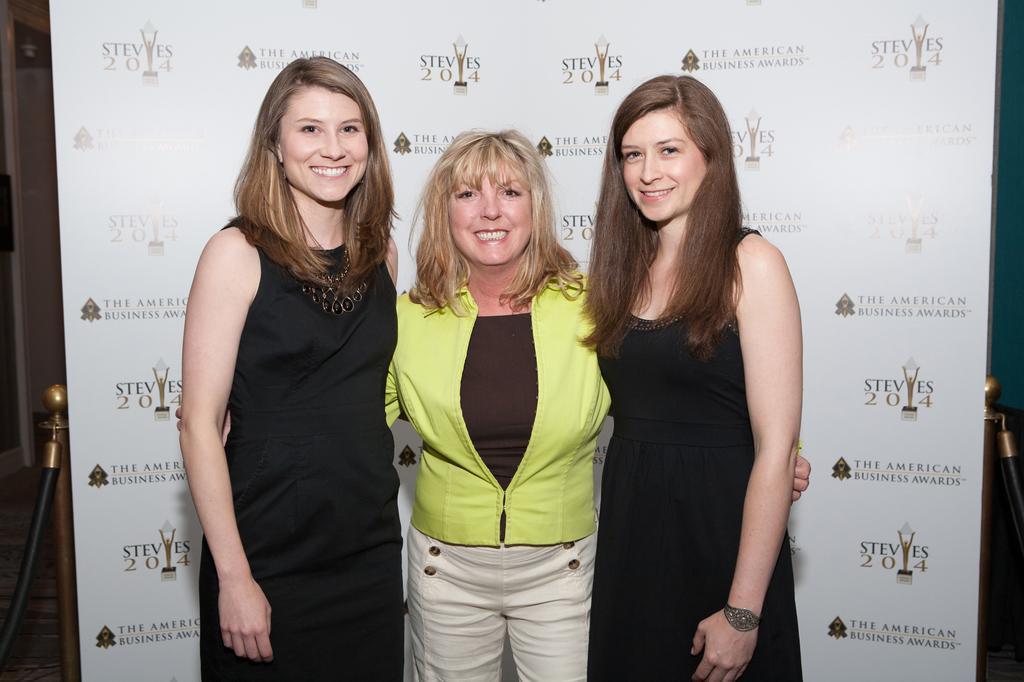In one or two sentences, can you explain what this image depicts? In the center of the image we can see three ladies standing and smiling. In the background there is a board. 